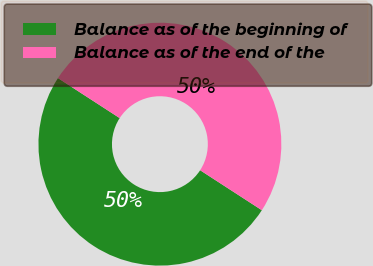Convert chart to OTSL. <chart><loc_0><loc_0><loc_500><loc_500><pie_chart><fcel>Balance as of the beginning of<fcel>Balance as of the end of the<nl><fcel>50.0%<fcel>50.0%<nl></chart> 